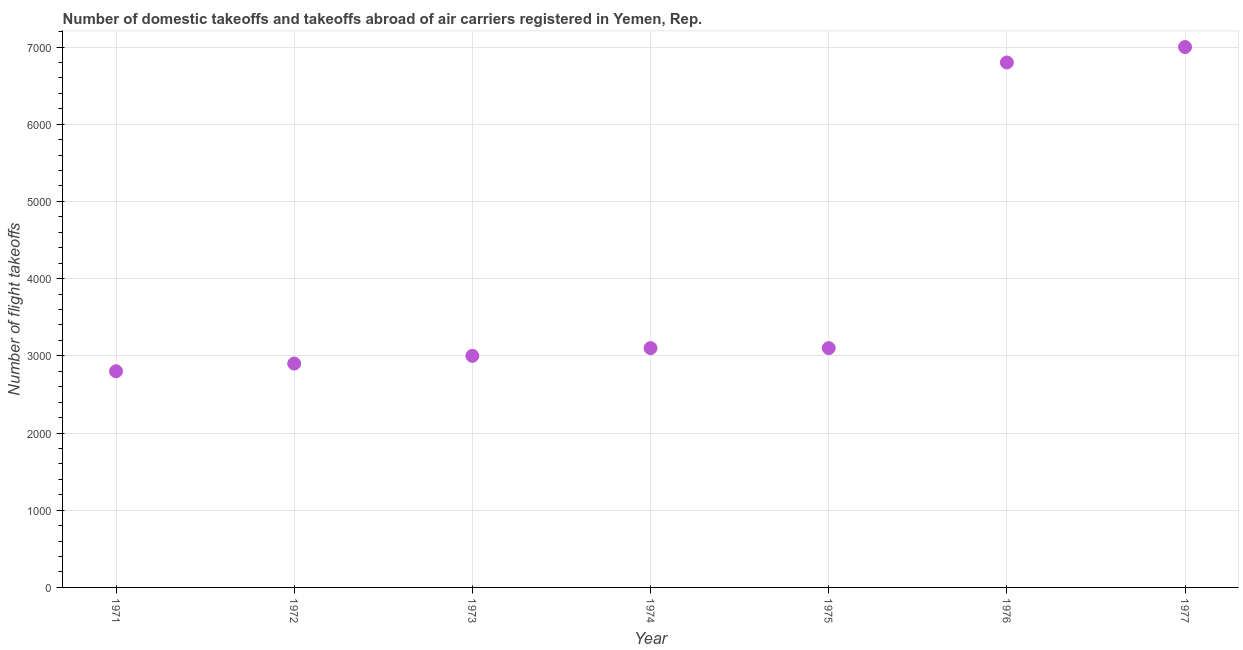What is the number of flight takeoffs in 1975?
Provide a short and direct response. 3100. Across all years, what is the maximum number of flight takeoffs?
Your response must be concise. 7000. Across all years, what is the minimum number of flight takeoffs?
Offer a terse response. 2800. In which year was the number of flight takeoffs maximum?
Ensure brevity in your answer.  1977. In which year was the number of flight takeoffs minimum?
Your answer should be very brief. 1971. What is the sum of the number of flight takeoffs?
Provide a short and direct response. 2.87e+04. What is the difference between the number of flight takeoffs in 1972 and 1977?
Ensure brevity in your answer.  -4100. What is the average number of flight takeoffs per year?
Provide a succinct answer. 4100. What is the median number of flight takeoffs?
Give a very brief answer. 3100. In how many years, is the number of flight takeoffs greater than 200 ?
Keep it short and to the point. 7. Do a majority of the years between 1975 and 1972 (inclusive) have number of flight takeoffs greater than 1800 ?
Make the answer very short. Yes. What is the ratio of the number of flight takeoffs in 1975 to that in 1976?
Offer a very short reply. 0.46. Is the number of flight takeoffs in 1976 less than that in 1977?
Make the answer very short. Yes. Is the difference between the number of flight takeoffs in 1974 and 1975 greater than the difference between any two years?
Provide a short and direct response. No. What is the difference between the highest and the second highest number of flight takeoffs?
Ensure brevity in your answer.  200. Is the sum of the number of flight takeoffs in 1972 and 1976 greater than the maximum number of flight takeoffs across all years?
Provide a succinct answer. Yes. What is the difference between the highest and the lowest number of flight takeoffs?
Ensure brevity in your answer.  4200. What is the difference between two consecutive major ticks on the Y-axis?
Ensure brevity in your answer.  1000. Are the values on the major ticks of Y-axis written in scientific E-notation?
Your response must be concise. No. Does the graph contain grids?
Your response must be concise. Yes. What is the title of the graph?
Make the answer very short. Number of domestic takeoffs and takeoffs abroad of air carriers registered in Yemen, Rep. What is the label or title of the Y-axis?
Provide a short and direct response. Number of flight takeoffs. What is the Number of flight takeoffs in 1971?
Provide a short and direct response. 2800. What is the Number of flight takeoffs in 1972?
Keep it short and to the point. 2900. What is the Number of flight takeoffs in 1973?
Give a very brief answer. 3000. What is the Number of flight takeoffs in 1974?
Keep it short and to the point. 3100. What is the Number of flight takeoffs in 1975?
Make the answer very short. 3100. What is the Number of flight takeoffs in 1976?
Your answer should be very brief. 6800. What is the Number of flight takeoffs in 1977?
Ensure brevity in your answer.  7000. What is the difference between the Number of flight takeoffs in 1971 and 1972?
Offer a terse response. -100. What is the difference between the Number of flight takeoffs in 1971 and 1973?
Provide a succinct answer. -200. What is the difference between the Number of flight takeoffs in 1971 and 1974?
Ensure brevity in your answer.  -300. What is the difference between the Number of flight takeoffs in 1971 and 1975?
Make the answer very short. -300. What is the difference between the Number of flight takeoffs in 1971 and 1976?
Offer a very short reply. -4000. What is the difference between the Number of flight takeoffs in 1971 and 1977?
Offer a very short reply. -4200. What is the difference between the Number of flight takeoffs in 1972 and 1973?
Provide a short and direct response. -100. What is the difference between the Number of flight takeoffs in 1972 and 1974?
Your answer should be very brief. -200. What is the difference between the Number of flight takeoffs in 1972 and 1975?
Provide a short and direct response. -200. What is the difference between the Number of flight takeoffs in 1972 and 1976?
Provide a short and direct response. -3900. What is the difference between the Number of flight takeoffs in 1972 and 1977?
Ensure brevity in your answer.  -4100. What is the difference between the Number of flight takeoffs in 1973 and 1974?
Ensure brevity in your answer.  -100. What is the difference between the Number of flight takeoffs in 1973 and 1975?
Offer a very short reply. -100. What is the difference between the Number of flight takeoffs in 1973 and 1976?
Your response must be concise. -3800. What is the difference between the Number of flight takeoffs in 1973 and 1977?
Keep it short and to the point. -4000. What is the difference between the Number of flight takeoffs in 1974 and 1976?
Ensure brevity in your answer.  -3700. What is the difference between the Number of flight takeoffs in 1974 and 1977?
Offer a very short reply. -3900. What is the difference between the Number of flight takeoffs in 1975 and 1976?
Your answer should be very brief. -3700. What is the difference between the Number of flight takeoffs in 1975 and 1977?
Give a very brief answer. -3900. What is the difference between the Number of flight takeoffs in 1976 and 1977?
Offer a very short reply. -200. What is the ratio of the Number of flight takeoffs in 1971 to that in 1973?
Ensure brevity in your answer.  0.93. What is the ratio of the Number of flight takeoffs in 1971 to that in 1974?
Your answer should be compact. 0.9. What is the ratio of the Number of flight takeoffs in 1971 to that in 1975?
Ensure brevity in your answer.  0.9. What is the ratio of the Number of flight takeoffs in 1971 to that in 1976?
Your response must be concise. 0.41. What is the ratio of the Number of flight takeoffs in 1971 to that in 1977?
Provide a succinct answer. 0.4. What is the ratio of the Number of flight takeoffs in 1972 to that in 1973?
Offer a very short reply. 0.97. What is the ratio of the Number of flight takeoffs in 1972 to that in 1974?
Your response must be concise. 0.94. What is the ratio of the Number of flight takeoffs in 1972 to that in 1975?
Offer a very short reply. 0.94. What is the ratio of the Number of flight takeoffs in 1972 to that in 1976?
Provide a succinct answer. 0.43. What is the ratio of the Number of flight takeoffs in 1972 to that in 1977?
Provide a short and direct response. 0.41. What is the ratio of the Number of flight takeoffs in 1973 to that in 1974?
Offer a very short reply. 0.97. What is the ratio of the Number of flight takeoffs in 1973 to that in 1976?
Ensure brevity in your answer.  0.44. What is the ratio of the Number of flight takeoffs in 1973 to that in 1977?
Offer a terse response. 0.43. What is the ratio of the Number of flight takeoffs in 1974 to that in 1975?
Your answer should be compact. 1. What is the ratio of the Number of flight takeoffs in 1974 to that in 1976?
Your response must be concise. 0.46. What is the ratio of the Number of flight takeoffs in 1974 to that in 1977?
Offer a very short reply. 0.44. What is the ratio of the Number of flight takeoffs in 1975 to that in 1976?
Make the answer very short. 0.46. What is the ratio of the Number of flight takeoffs in 1975 to that in 1977?
Give a very brief answer. 0.44. 